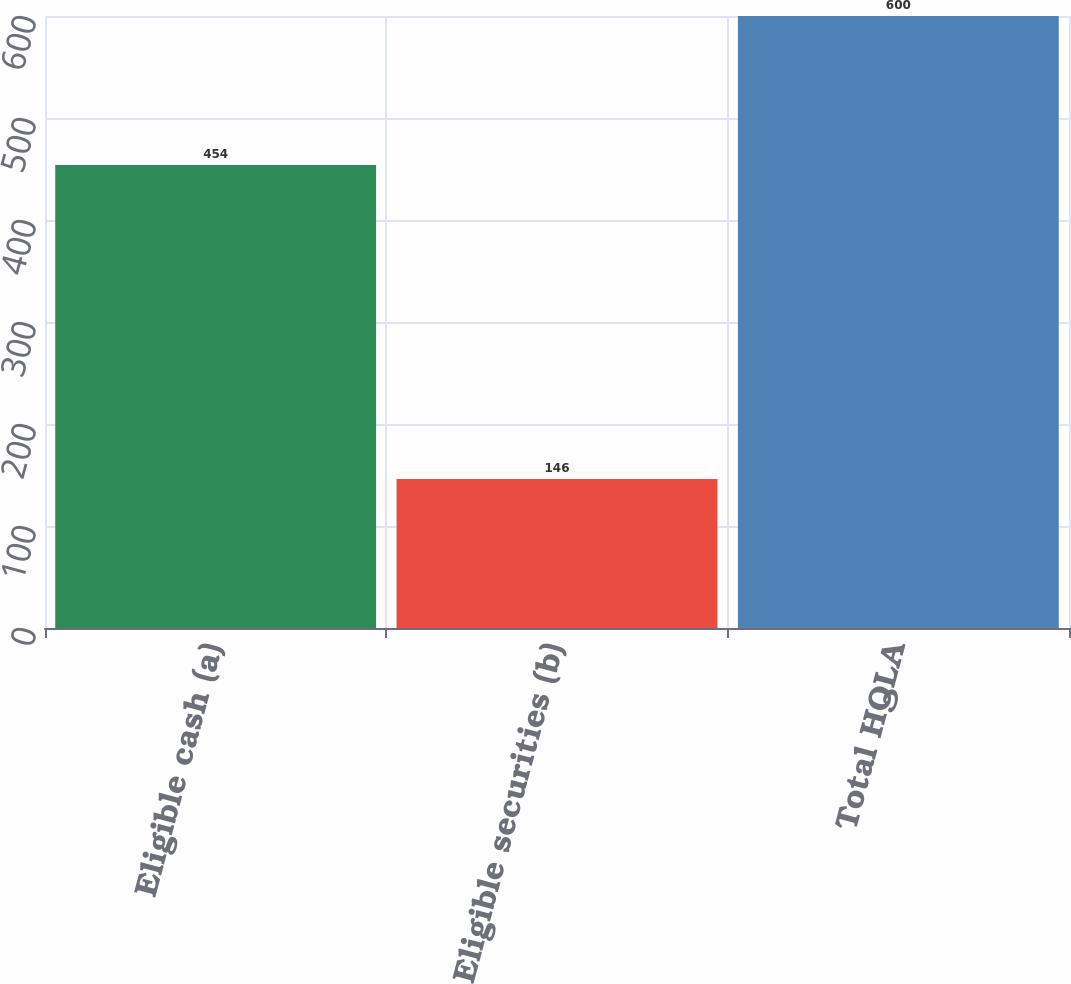<chart> <loc_0><loc_0><loc_500><loc_500><bar_chart><fcel>Eligible cash (a)<fcel>Eligible securities (b)<fcel>Total HQLA<nl><fcel>454<fcel>146<fcel>600<nl></chart> 